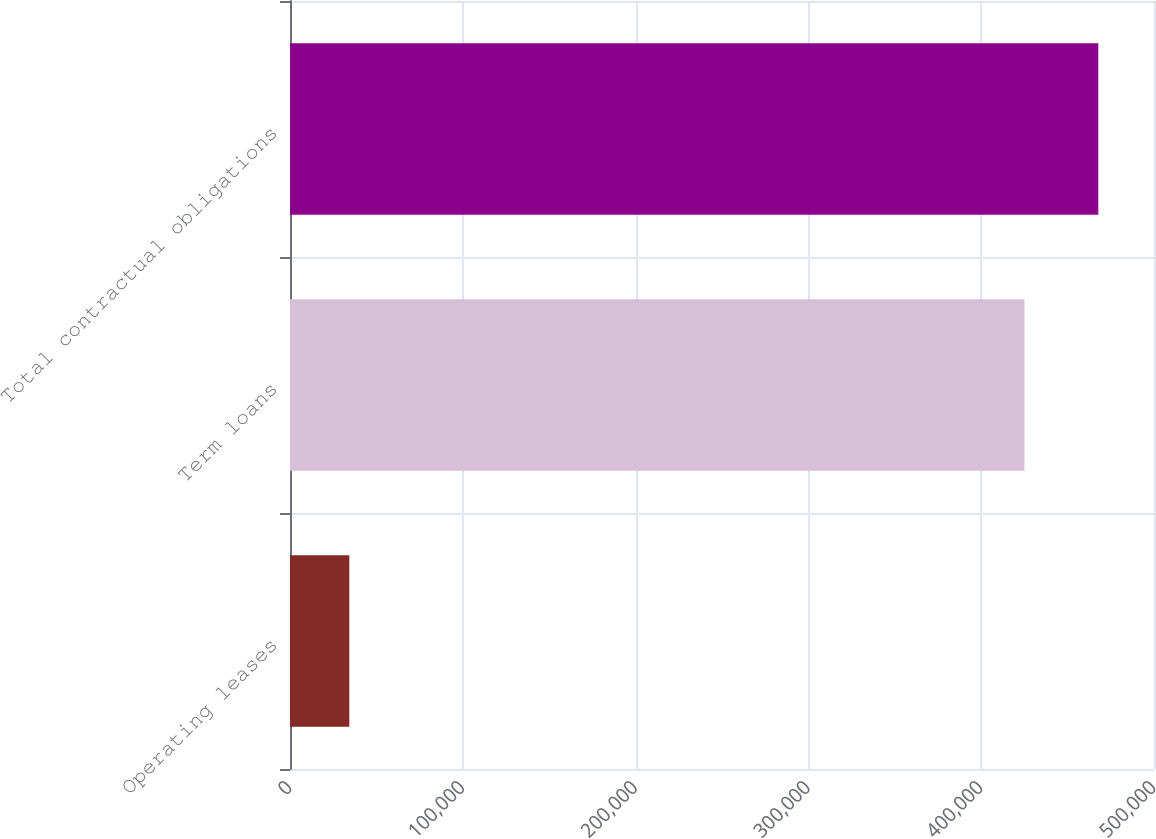Convert chart. <chart><loc_0><loc_0><loc_500><loc_500><bar_chart><fcel>Operating leases<fcel>Term loans<fcel>Total contractual obligations<nl><fcel>34333<fcel>425000<fcel>467764<nl></chart> 